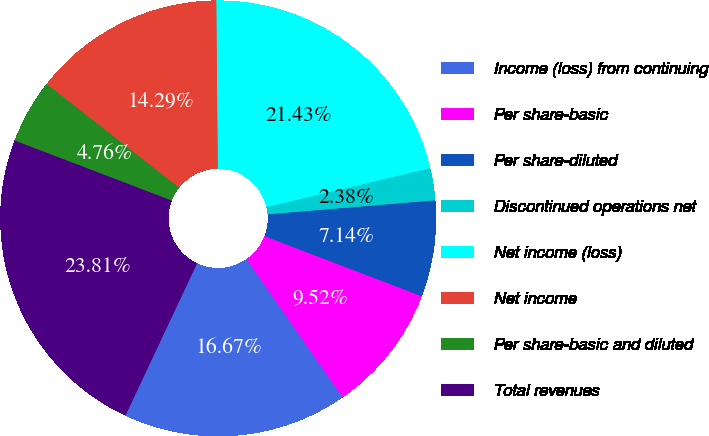Convert chart. <chart><loc_0><loc_0><loc_500><loc_500><pie_chart><fcel>Income (loss) from continuing<fcel>Per share-basic<fcel>Per share-diluted<fcel>Discontinued operations net<fcel>Net income (loss)<fcel>Net income<fcel>Per share-basic and diluted<fcel>Total revenues<nl><fcel>16.67%<fcel>9.52%<fcel>7.14%<fcel>2.38%<fcel>21.43%<fcel>14.29%<fcel>4.76%<fcel>23.81%<nl></chart> 